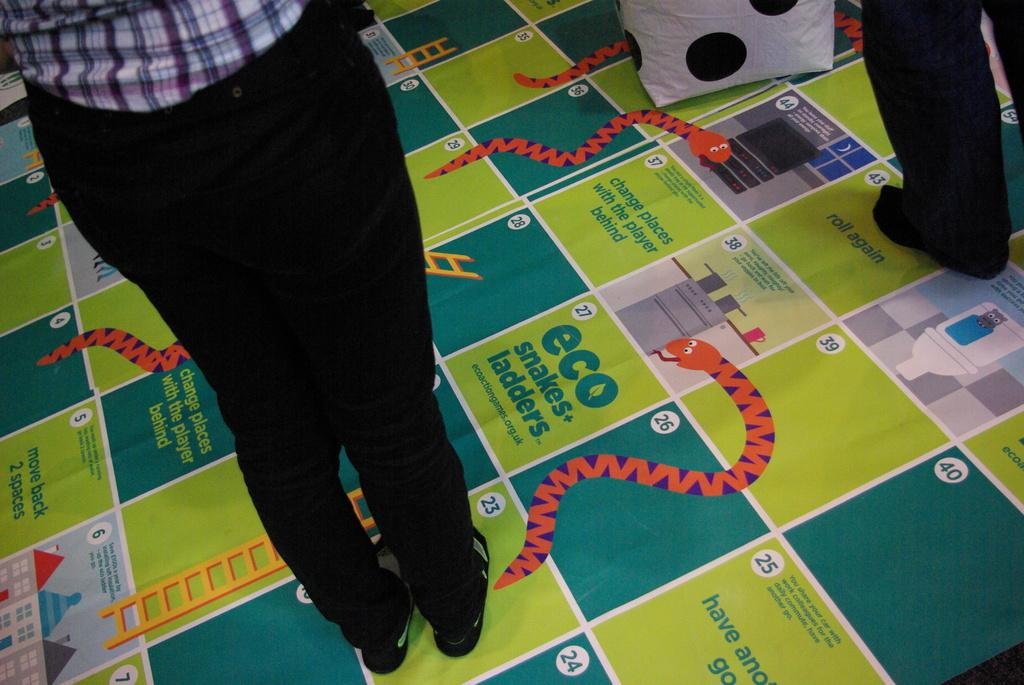How many people are in the image? There are two persons standing in the image. What is the object on the snake and ladder board in the image? The provided facts do not specify the object on the snake and ladder board. How many ladybugs are crawling on the cloud in the image? There are no ladybugs or clouds present in the image. 